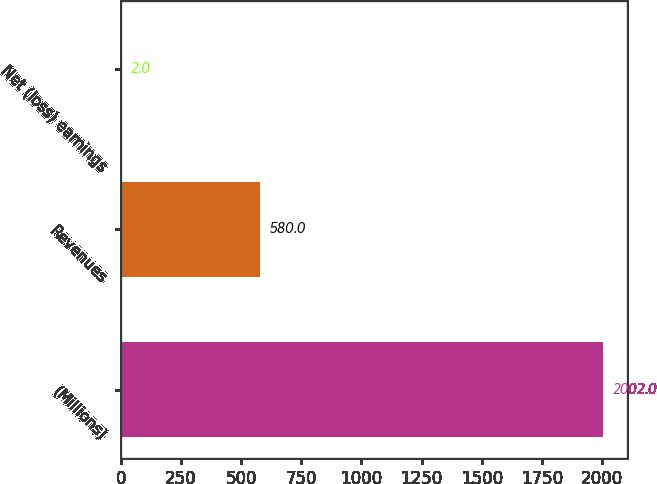Convert chart to OTSL. <chart><loc_0><loc_0><loc_500><loc_500><bar_chart><fcel>(Millions)<fcel>Revenues<fcel>Net (loss) earnings<nl><fcel>2002<fcel>580<fcel>2<nl></chart> 